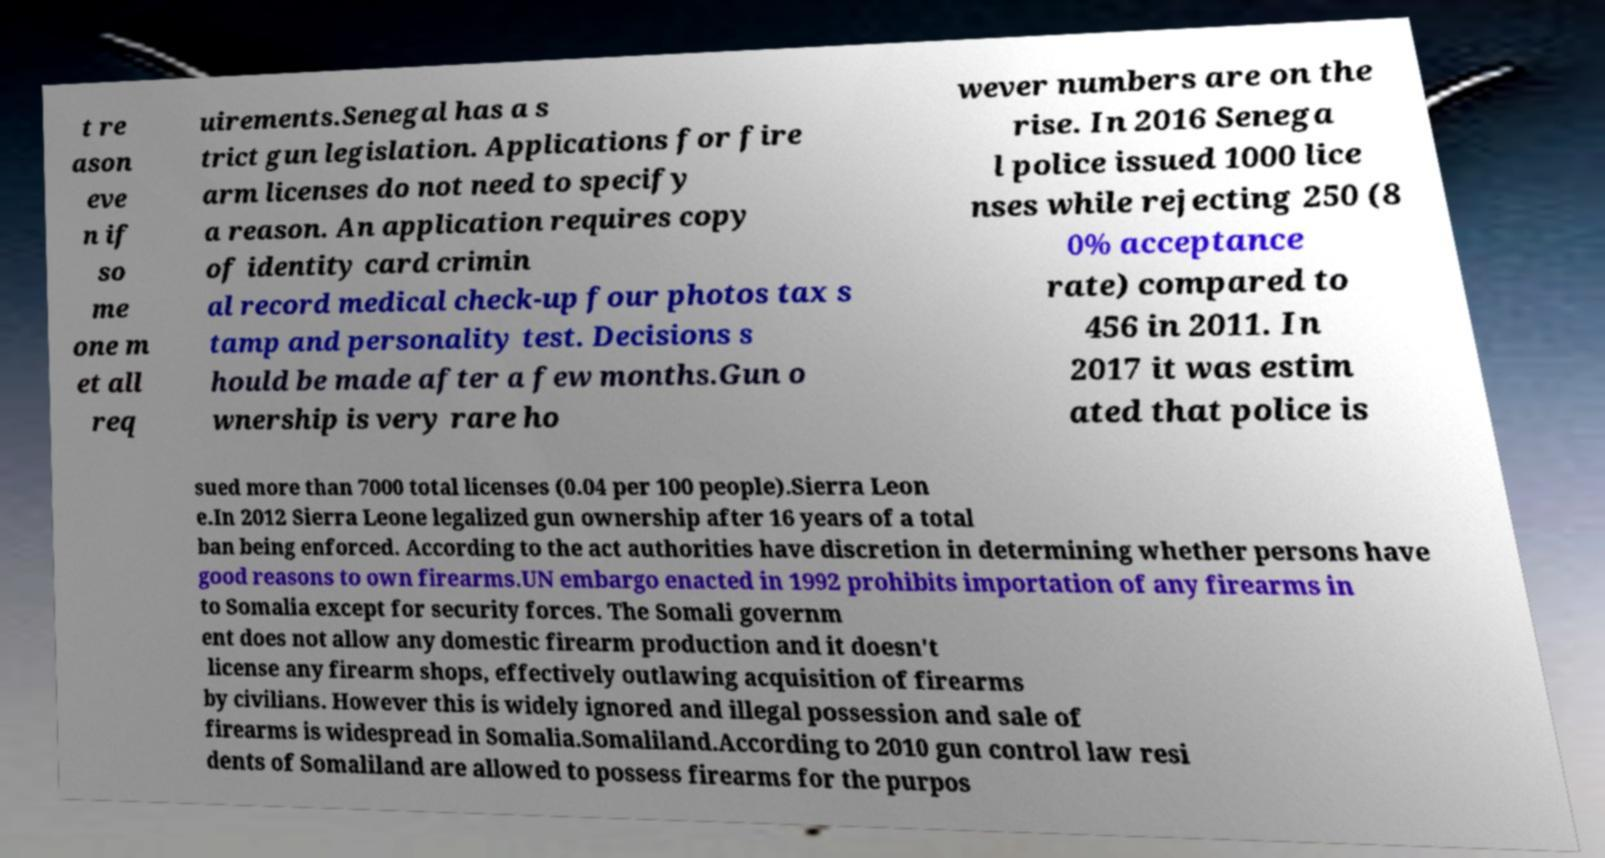Can you accurately transcribe the text from the provided image for me? t re ason eve n if so me one m et all req uirements.Senegal has a s trict gun legislation. Applications for fire arm licenses do not need to specify a reason. An application requires copy of identity card crimin al record medical check-up four photos tax s tamp and personality test. Decisions s hould be made after a few months.Gun o wnership is very rare ho wever numbers are on the rise. In 2016 Senega l police issued 1000 lice nses while rejecting 250 (8 0% acceptance rate) compared to 456 in 2011. In 2017 it was estim ated that police is sued more than 7000 total licenses (0.04 per 100 people).Sierra Leon e.In 2012 Sierra Leone legalized gun ownership after 16 years of a total ban being enforced. According to the act authorities have discretion in determining whether persons have good reasons to own firearms.UN embargo enacted in 1992 prohibits importation of any firearms in to Somalia except for security forces. The Somali governm ent does not allow any domestic firearm production and it doesn't license any firearm shops, effectively outlawing acquisition of firearms by civilians. However this is widely ignored and illegal possession and sale of firearms is widespread in Somalia.Somaliland.According to 2010 gun control law resi dents of Somaliland are allowed to possess firearms for the purpos 